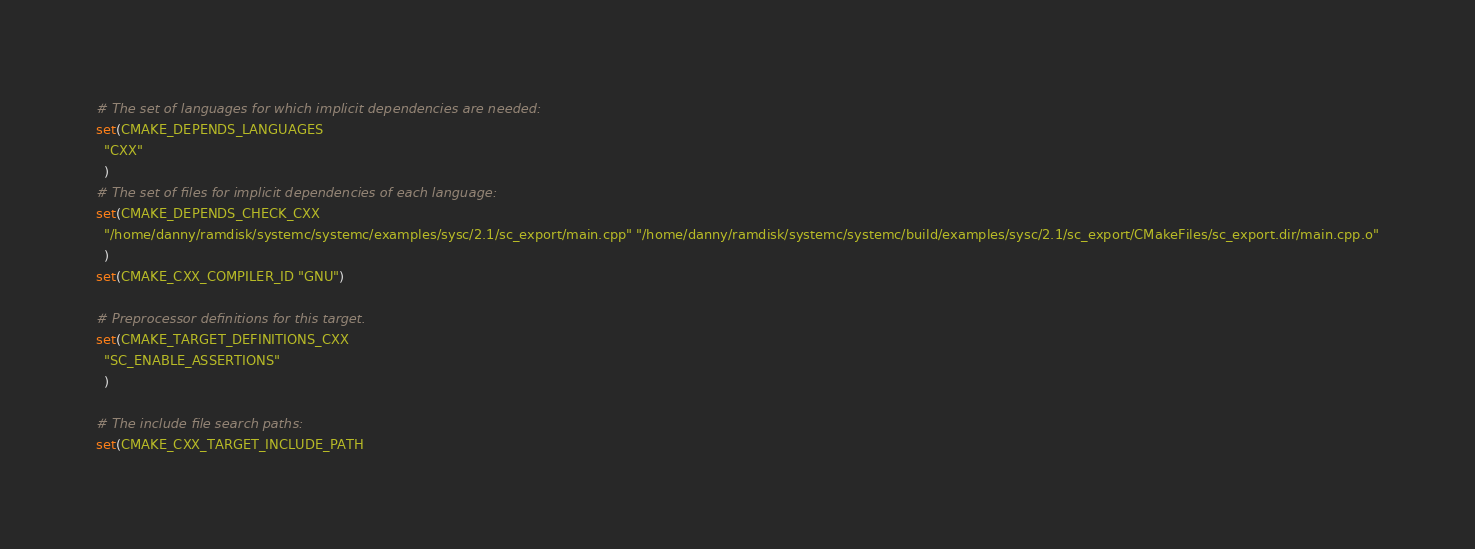Convert code to text. <code><loc_0><loc_0><loc_500><loc_500><_CMake_># The set of languages for which implicit dependencies are needed:
set(CMAKE_DEPENDS_LANGUAGES
  "CXX"
  )
# The set of files for implicit dependencies of each language:
set(CMAKE_DEPENDS_CHECK_CXX
  "/home/danny/ramdisk/systemc/systemc/examples/sysc/2.1/sc_export/main.cpp" "/home/danny/ramdisk/systemc/systemc/build/examples/sysc/2.1/sc_export/CMakeFiles/sc_export.dir/main.cpp.o"
  )
set(CMAKE_CXX_COMPILER_ID "GNU")

# Preprocessor definitions for this target.
set(CMAKE_TARGET_DEFINITIONS_CXX
  "SC_ENABLE_ASSERTIONS"
  )

# The include file search paths:
set(CMAKE_CXX_TARGET_INCLUDE_PATH</code> 